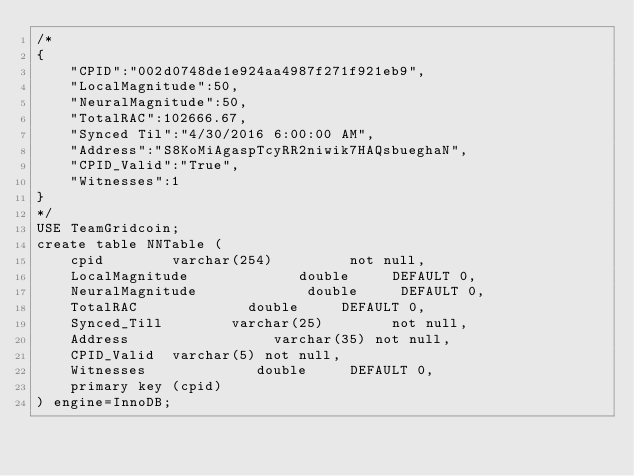<code> <loc_0><loc_0><loc_500><loc_500><_SQL_>/*
{
    "CPID":"002d0748de1e924aa4987f271f921eb9",
    "LocalMagnitude":50,
    "NeuralMagnitude":50,
    "TotalRAC":102666.67,
    "Synced Til":"4/30/2016 6:00:00 AM",
    "Address":"S8KoMiAgaspTcyRR2niwik7HAQsbueghaN",
    "CPID_Valid":"True",
    "Witnesses":1
}
*/
USE TeamGridcoin;
create table NNTable (
    cpid        varchar(254)         not null,
    LocalMagnitude             double     DEFAULT 0,
    NeuralMagnitude             double     DEFAULT 0,
    TotalRAC             double     DEFAULT 0,
    Synced_Till        varchar(25)        not null,
    Address                 varchar(35) not null,
    CPID_Valid  varchar(5) not null,
    Witnesses             double     DEFAULT 0,
    primary key (cpid)
) engine=InnoDB;</code> 